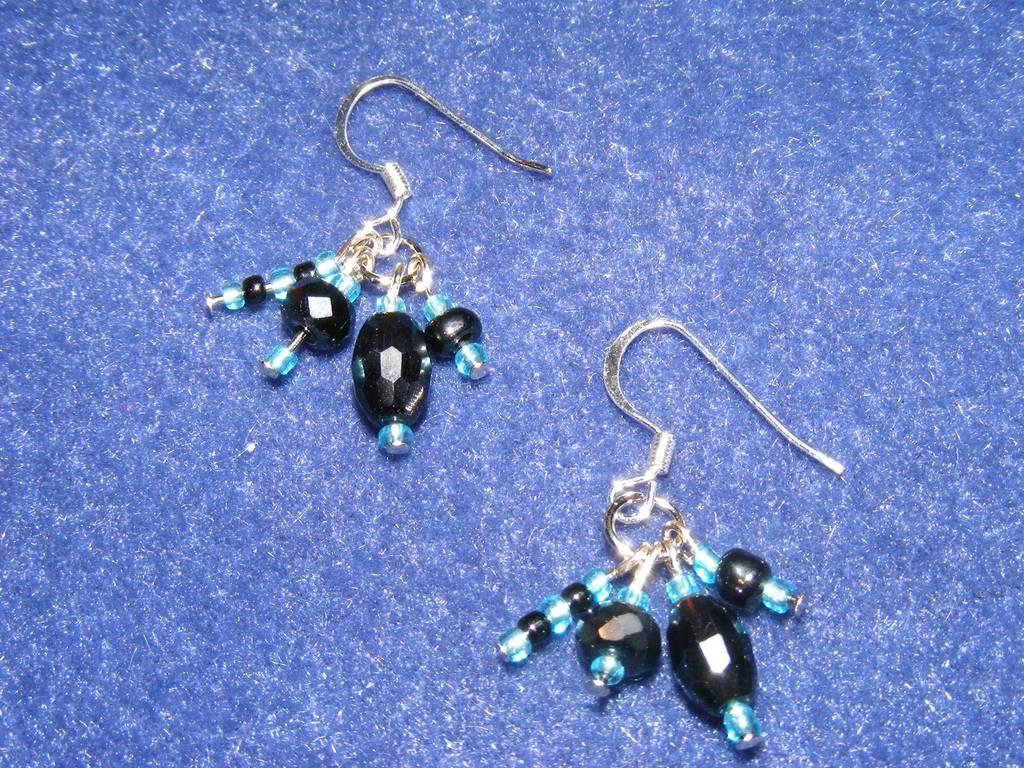Describe this image in one or two sentences. In this image we can see there are earrings placed on the surface of the floor. 